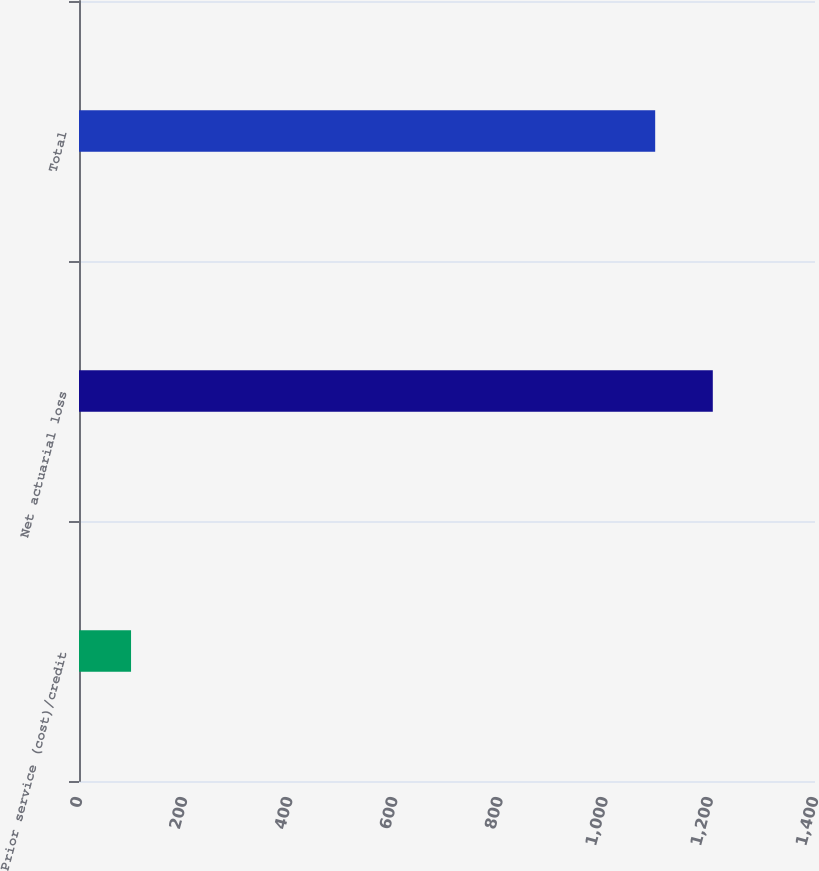<chart> <loc_0><loc_0><loc_500><loc_500><bar_chart><fcel>Prior service (cost)/credit<fcel>Net actuarial loss<fcel>Total<nl><fcel>99<fcel>1205.6<fcel>1096<nl></chart> 